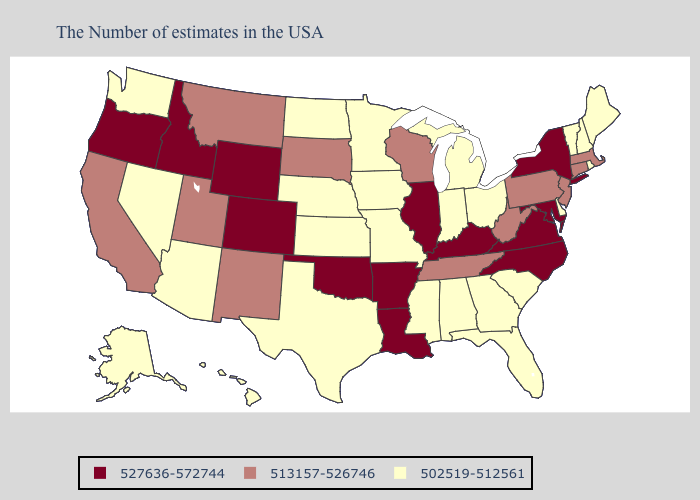What is the highest value in the South ?
Be succinct. 527636-572744. What is the highest value in the USA?
Be succinct. 527636-572744. What is the highest value in the MidWest ?
Concise answer only. 527636-572744. Does Florida have the highest value in the USA?
Write a very short answer. No. Does Hawaii have a lower value than Montana?
Concise answer only. Yes. Which states hav the highest value in the West?
Concise answer only. Wyoming, Colorado, Idaho, Oregon. Name the states that have a value in the range 513157-526746?
Short answer required. Massachusetts, Connecticut, New Jersey, Pennsylvania, West Virginia, Tennessee, Wisconsin, South Dakota, New Mexico, Utah, Montana, California. How many symbols are there in the legend?
Give a very brief answer. 3. Does New York have the highest value in the USA?
Quick response, please. Yes. What is the value of Mississippi?
Keep it brief. 502519-512561. Name the states that have a value in the range 502519-512561?
Be succinct. Maine, Rhode Island, New Hampshire, Vermont, Delaware, South Carolina, Ohio, Florida, Georgia, Michigan, Indiana, Alabama, Mississippi, Missouri, Minnesota, Iowa, Kansas, Nebraska, Texas, North Dakota, Arizona, Nevada, Washington, Alaska, Hawaii. Is the legend a continuous bar?
Quick response, please. No. Which states have the highest value in the USA?
Concise answer only. New York, Maryland, Virginia, North Carolina, Kentucky, Illinois, Louisiana, Arkansas, Oklahoma, Wyoming, Colorado, Idaho, Oregon. What is the lowest value in the Northeast?
Be succinct. 502519-512561. Which states have the highest value in the USA?
Give a very brief answer. New York, Maryland, Virginia, North Carolina, Kentucky, Illinois, Louisiana, Arkansas, Oklahoma, Wyoming, Colorado, Idaho, Oregon. 